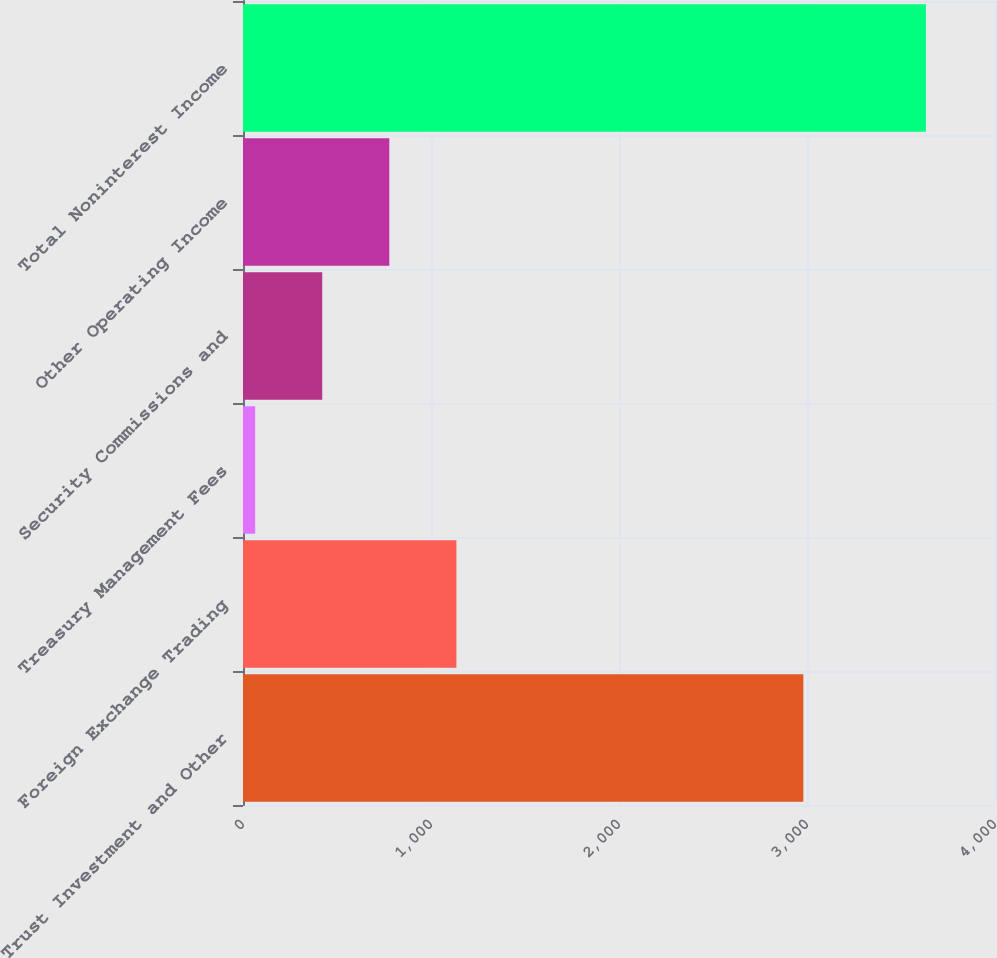Convert chart. <chart><loc_0><loc_0><loc_500><loc_500><bar_chart><fcel>Trust Investment and Other<fcel>Foreign Exchange Trading<fcel>Treasury Management Fees<fcel>Security Commissions and<fcel>Other Operating Income<fcel>Total Noninterest Income<nl><fcel>2980.5<fcel>1135.04<fcel>64.7<fcel>421.48<fcel>778.26<fcel>3632.5<nl></chart> 